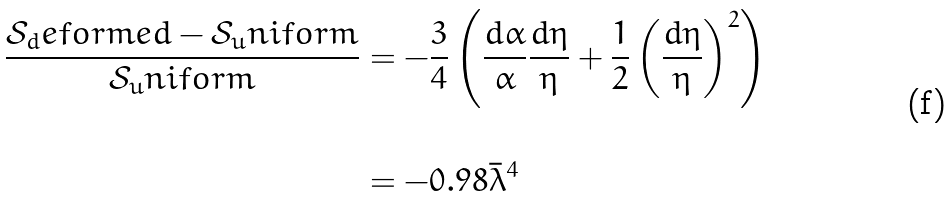<formula> <loc_0><loc_0><loc_500><loc_500>\frac { \mathcal { S } _ { d } e f o r m e d - \mathcal { S } _ { u } n i f o r m } { \mathcal { S } _ { u } n i f o r m } & = - \frac { 3 } { 4 } \left ( \frac { d \alpha } { \alpha } \frac { d \eta } { \eta } + \frac { 1 } { 2 } \left ( \frac { d \eta } { \eta } \right ) ^ { 2 } \right ) \\ \\ & = - 0 . 9 8 \bar { \lambda } ^ { 4 }</formula> 